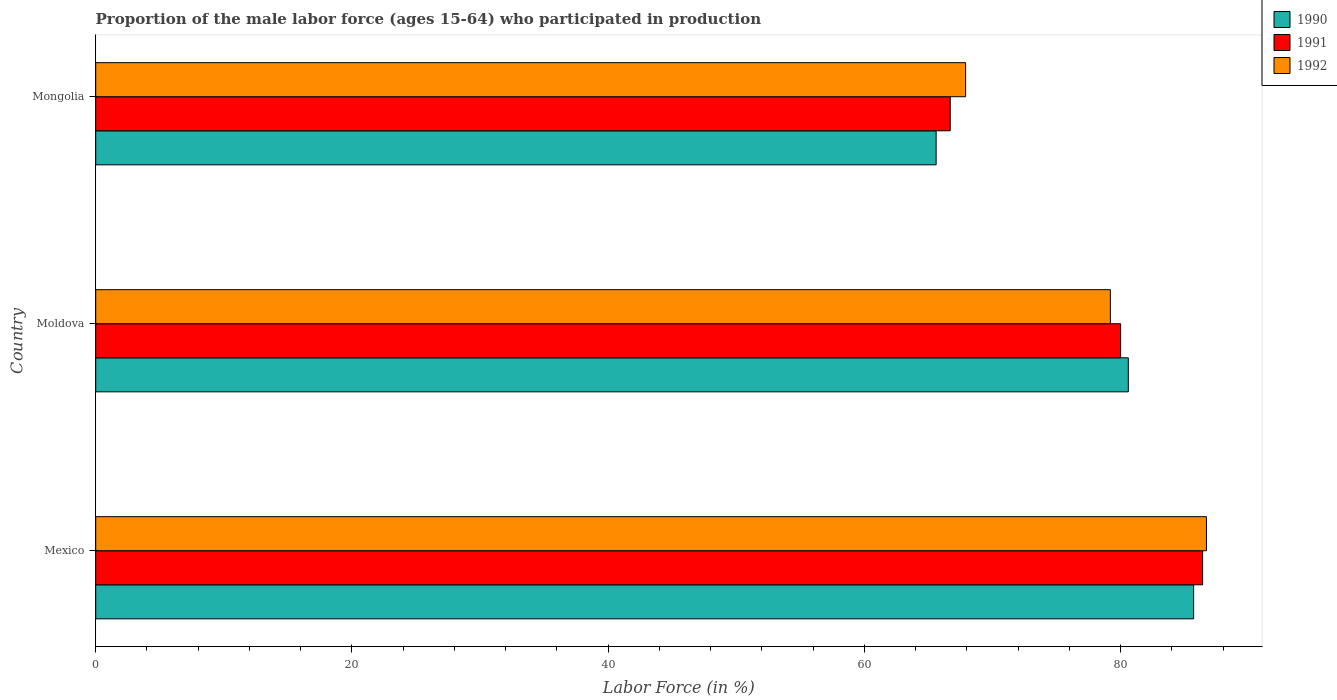Are the number of bars on each tick of the Y-axis equal?
Your answer should be compact. Yes. How many bars are there on the 2nd tick from the top?
Your answer should be very brief. 3. In how many cases, is the number of bars for a given country not equal to the number of legend labels?
Provide a short and direct response. 0. What is the proportion of the male labor force who participated in production in 1992 in Moldova?
Offer a very short reply. 79.2. Across all countries, what is the maximum proportion of the male labor force who participated in production in 1990?
Your answer should be compact. 85.7. Across all countries, what is the minimum proportion of the male labor force who participated in production in 1990?
Make the answer very short. 65.6. In which country was the proportion of the male labor force who participated in production in 1991 minimum?
Provide a succinct answer. Mongolia. What is the total proportion of the male labor force who participated in production in 1992 in the graph?
Keep it short and to the point. 233.8. What is the difference between the proportion of the male labor force who participated in production in 1991 in Mexico and that in Mongolia?
Your answer should be compact. 19.7. What is the difference between the proportion of the male labor force who participated in production in 1991 in Mongolia and the proportion of the male labor force who participated in production in 1992 in Mexico?
Offer a terse response. -20. What is the average proportion of the male labor force who participated in production in 1990 per country?
Your answer should be compact. 77.3. What is the difference between the proportion of the male labor force who participated in production in 1991 and proportion of the male labor force who participated in production in 1990 in Moldova?
Give a very brief answer. -0.6. In how many countries, is the proportion of the male labor force who participated in production in 1992 greater than 80 %?
Keep it short and to the point. 1. What is the ratio of the proportion of the male labor force who participated in production in 1992 in Moldova to that in Mongolia?
Keep it short and to the point. 1.17. What is the difference between the highest and the second highest proportion of the male labor force who participated in production in 1991?
Provide a succinct answer. 6.4. What is the difference between the highest and the lowest proportion of the male labor force who participated in production in 1992?
Give a very brief answer. 18.8. What does the 3rd bar from the top in Moldova represents?
Your response must be concise. 1990. Are all the bars in the graph horizontal?
Your response must be concise. Yes. Are the values on the major ticks of X-axis written in scientific E-notation?
Provide a succinct answer. No. Does the graph contain any zero values?
Your answer should be compact. No. Where does the legend appear in the graph?
Your answer should be very brief. Top right. How are the legend labels stacked?
Keep it short and to the point. Vertical. What is the title of the graph?
Your answer should be very brief. Proportion of the male labor force (ages 15-64) who participated in production. What is the label or title of the Y-axis?
Your answer should be compact. Country. What is the Labor Force (in %) in 1990 in Mexico?
Keep it short and to the point. 85.7. What is the Labor Force (in %) in 1991 in Mexico?
Provide a succinct answer. 86.4. What is the Labor Force (in %) of 1992 in Mexico?
Give a very brief answer. 86.7. What is the Labor Force (in %) of 1990 in Moldova?
Keep it short and to the point. 80.6. What is the Labor Force (in %) in 1991 in Moldova?
Provide a succinct answer. 80. What is the Labor Force (in %) of 1992 in Moldova?
Ensure brevity in your answer.  79.2. What is the Labor Force (in %) of 1990 in Mongolia?
Give a very brief answer. 65.6. What is the Labor Force (in %) in 1991 in Mongolia?
Provide a succinct answer. 66.7. What is the Labor Force (in %) in 1992 in Mongolia?
Give a very brief answer. 67.9. Across all countries, what is the maximum Labor Force (in %) of 1990?
Make the answer very short. 85.7. Across all countries, what is the maximum Labor Force (in %) of 1991?
Keep it short and to the point. 86.4. Across all countries, what is the maximum Labor Force (in %) of 1992?
Give a very brief answer. 86.7. Across all countries, what is the minimum Labor Force (in %) of 1990?
Keep it short and to the point. 65.6. Across all countries, what is the minimum Labor Force (in %) of 1991?
Make the answer very short. 66.7. Across all countries, what is the minimum Labor Force (in %) in 1992?
Provide a short and direct response. 67.9. What is the total Labor Force (in %) in 1990 in the graph?
Ensure brevity in your answer.  231.9. What is the total Labor Force (in %) of 1991 in the graph?
Keep it short and to the point. 233.1. What is the total Labor Force (in %) of 1992 in the graph?
Offer a very short reply. 233.8. What is the difference between the Labor Force (in %) of 1990 in Mexico and that in Moldova?
Your answer should be compact. 5.1. What is the difference between the Labor Force (in %) of 1990 in Mexico and that in Mongolia?
Offer a terse response. 20.1. What is the difference between the Labor Force (in %) of 1991 in Mexico and that in Mongolia?
Offer a very short reply. 19.7. What is the difference between the Labor Force (in %) in 1990 in Moldova and that in Mongolia?
Ensure brevity in your answer.  15. What is the difference between the Labor Force (in %) in 1991 in Moldova and that in Mongolia?
Your answer should be compact. 13.3. What is the difference between the Labor Force (in %) of 1991 in Mexico and the Labor Force (in %) of 1992 in Moldova?
Offer a terse response. 7.2. What is the difference between the Labor Force (in %) of 1990 in Mexico and the Labor Force (in %) of 1992 in Mongolia?
Your answer should be compact. 17.8. What is the difference between the Labor Force (in %) of 1990 in Moldova and the Labor Force (in %) of 1991 in Mongolia?
Give a very brief answer. 13.9. What is the average Labor Force (in %) of 1990 per country?
Your answer should be very brief. 77.3. What is the average Labor Force (in %) of 1991 per country?
Make the answer very short. 77.7. What is the average Labor Force (in %) in 1992 per country?
Offer a terse response. 77.93. What is the difference between the Labor Force (in %) of 1990 and Labor Force (in %) of 1991 in Moldova?
Ensure brevity in your answer.  0.6. What is the difference between the Labor Force (in %) in 1991 and Labor Force (in %) in 1992 in Mongolia?
Offer a very short reply. -1.2. What is the ratio of the Labor Force (in %) of 1990 in Mexico to that in Moldova?
Offer a terse response. 1.06. What is the ratio of the Labor Force (in %) of 1992 in Mexico to that in Moldova?
Provide a short and direct response. 1.09. What is the ratio of the Labor Force (in %) of 1990 in Mexico to that in Mongolia?
Ensure brevity in your answer.  1.31. What is the ratio of the Labor Force (in %) in 1991 in Mexico to that in Mongolia?
Provide a succinct answer. 1.3. What is the ratio of the Labor Force (in %) in 1992 in Mexico to that in Mongolia?
Provide a succinct answer. 1.28. What is the ratio of the Labor Force (in %) in 1990 in Moldova to that in Mongolia?
Keep it short and to the point. 1.23. What is the ratio of the Labor Force (in %) in 1991 in Moldova to that in Mongolia?
Keep it short and to the point. 1.2. What is the ratio of the Labor Force (in %) in 1992 in Moldova to that in Mongolia?
Offer a very short reply. 1.17. What is the difference between the highest and the second highest Labor Force (in %) of 1990?
Make the answer very short. 5.1. What is the difference between the highest and the lowest Labor Force (in %) in 1990?
Offer a very short reply. 20.1. What is the difference between the highest and the lowest Labor Force (in %) in 1991?
Offer a very short reply. 19.7. What is the difference between the highest and the lowest Labor Force (in %) of 1992?
Ensure brevity in your answer.  18.8. 